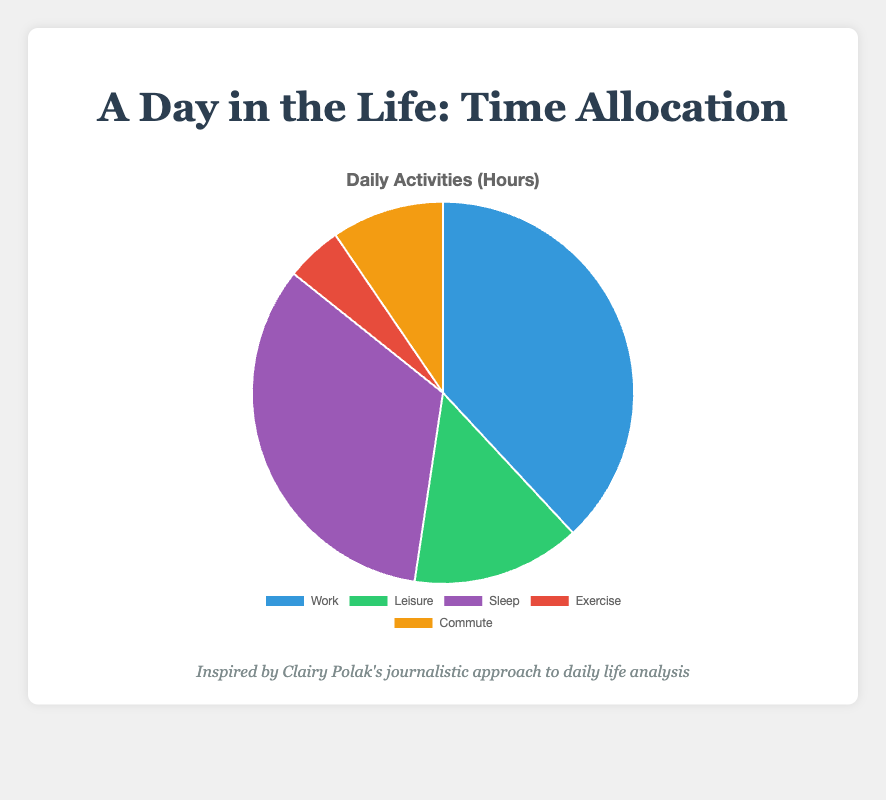What activity occupies the most time in a day? The largest segment in the pie chart represents the activity that occupies the most time. Here, the segment for "Work" is the largest, representing 8 hours.
Answer: Work Which activity is depicted in green in the pie chart? By looking at the color legend for the chart, the green segment corresponds to "Leisure."
Answer: Leisure What is the combined total of hours spent on Leisure and Exercise? Adding the time spent on "Leisure" (3 hours) and "Exercise" (1 hour) gives 3 + 1 = 4 hours.
Answer: 4 hours Is the time spent on Sleep greater than or equal to the time spent on Work? Comparing the segments, Sleep is represented by 7 hours and Work by 8 hours. Since 7 is less than 8, Sleep is not greater than or equal to Work.
Answer: No What fraction of the entire day is spent commuting? There are 24 hours in a day, and commuting takes 2 hours. The fraction is 2/24, which simplifies to 1/12.
Answer: 1/12 How many more hours are spent on Work compared to Exercise? The time difference between Work (8 hours) and Exercise (1 hour) is 8 - 1 = 7 hours.
Answer: 7 hours List the activities from most to least time spent. By examining the pie chart segments, the order from most to least is: Work (8), Sleep (7), Leisure (3), Commute (2), Exercise (1).
Answer: Work, Sleep, Leisure, Commute, Exercise What percentage of the day is dedicated to Sleep? To find the percentage, divide the time spent on Sleep (7 hours) by the total hours in a day (24 hours), then multiply by 100. Thus, (7/24) * 100 ≈ 29.17%.
Answer: 29.17% Is the sum of hours spent on Commute and Leisure more than the hours spent on Work? Adding the time for Commute (2 hours) and Leisure (3 hours) gives 2 + 3 = 5 hours. Since Work takes 8 hours, 5 hours is less than 8 hours.
Answer: No What activities take up half of the total day's hours when combined? The total hours available in a day are 24. Half of this is 24/2 = 12 hours. By adding the highest numbers first: Work (8) + Sleep (7) = 15, which is already more than 12. So, Work (8) and Leisure (3) make 8 + 3 = 11 hours. Adding Exercise (1) makes exactly 12 hours needed. So, Work (8), Leisure (3), and Exercise (1).
Answer: Work, Leisure, Exercise 